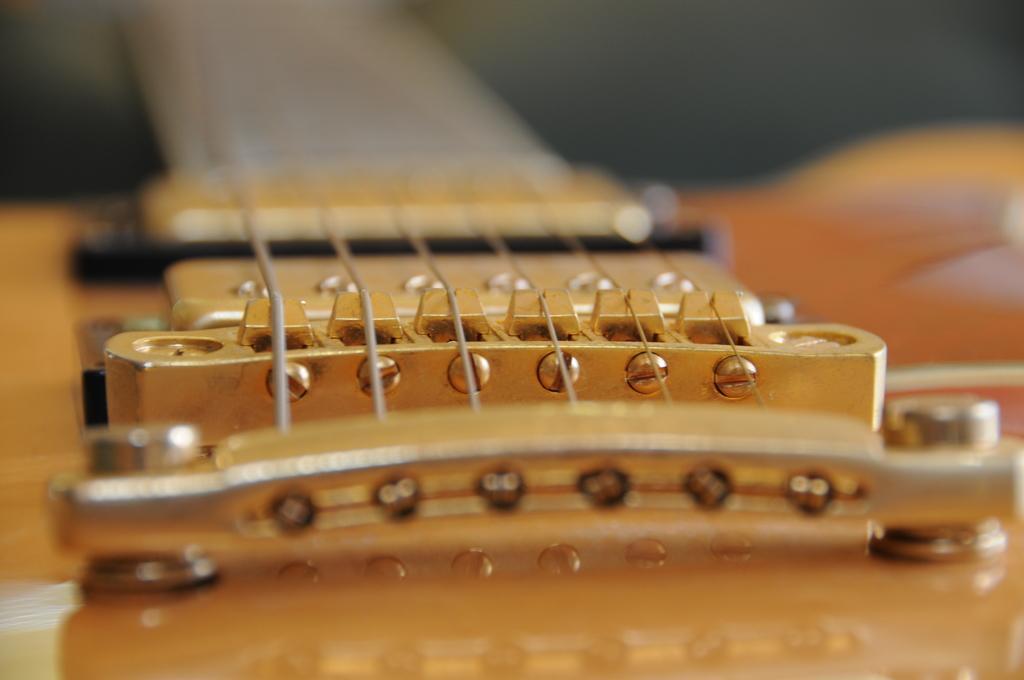In one or two sentences, can you explain what this image depicts? In the image in the center we can see the guitar strings. 